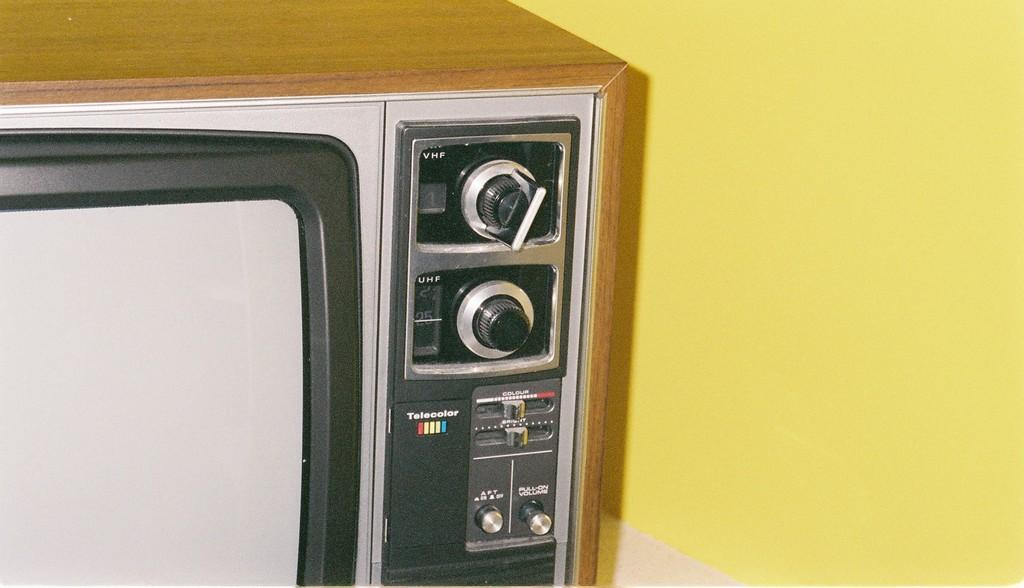<image>
Relay a brief, clear account of the picture shown. A television that offers both VHF and UHF channels. 